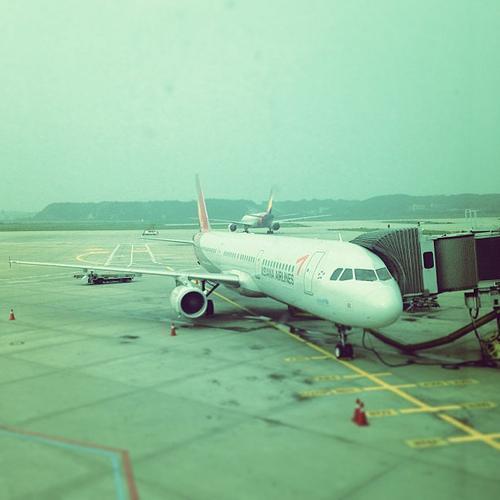How many planes are in the photo?
Give a very brief answer. 2. 